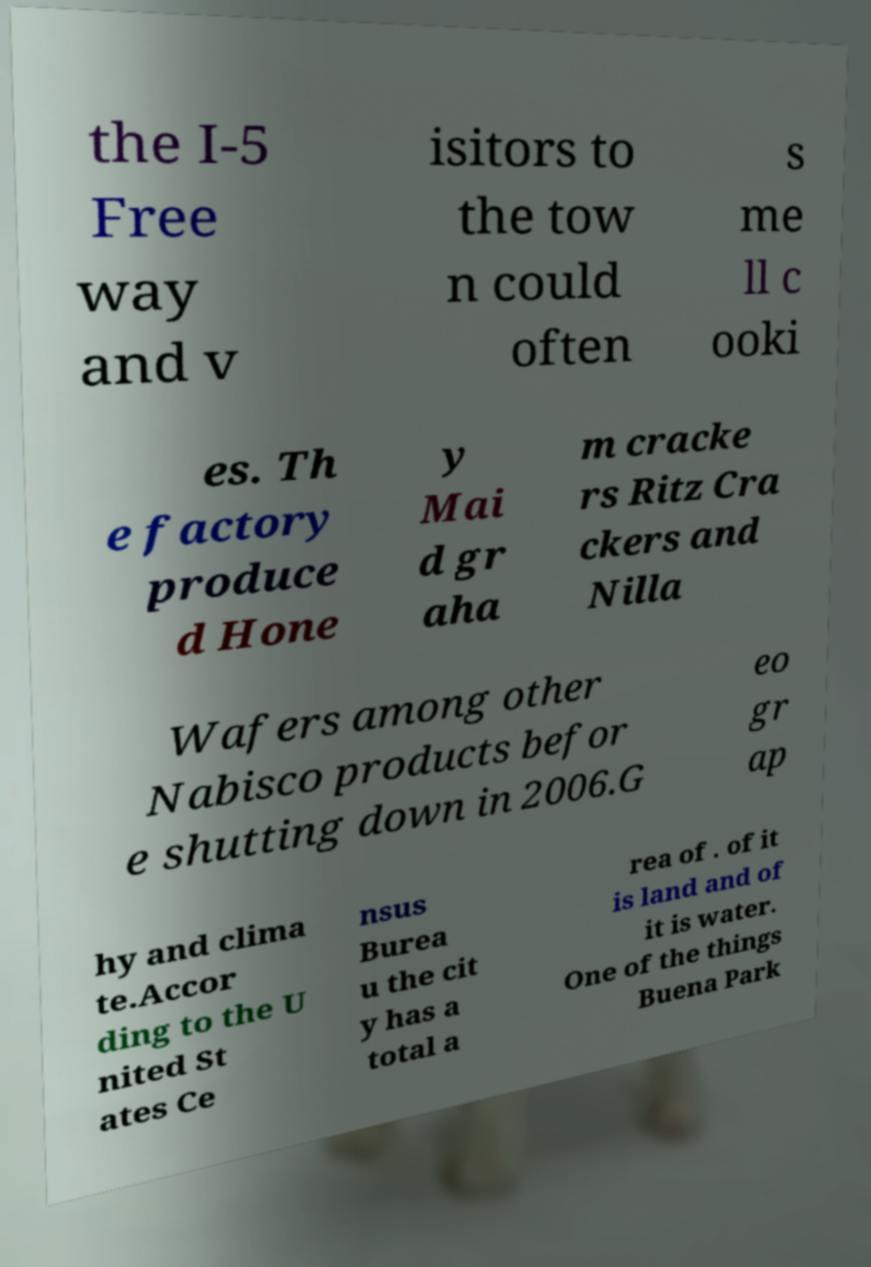Can you accurately transcribe the text from the provided image for me? the I-5 Free way and v isitors to the tow n could often s me ll c ooki es. Th e factory produce d Hone y Mai d gr aha m cracke rs Ritz Cra ckers and Nilla Wafers among other Nabisco products befor e shutting down in 2006.G eo gr ap hy and clima te.Accor ding to the U nited St ates Ce nsus Burea u the cit y has a total a rea of . of it is land and of it is water. One of the things Buena Park 